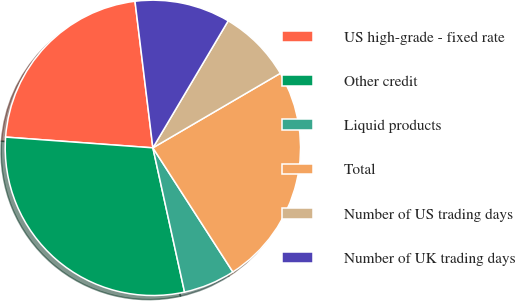Convert chart to OTSL. <chart><loc_0><loc_0><loc_500><loc_500><pie_chart><fcel>US high-grade - fixed rate<fcel>Other credit<fcel>Liquid products<fcel>Total<fcel>Number of US trading days<fcel>Number of UK trading days<nl><fcel>21.91%<fcel>29.6%<fcel>5.67%<fcel>24.31%<fcel>8.06%<fcel>10.45%<nl></chart> 